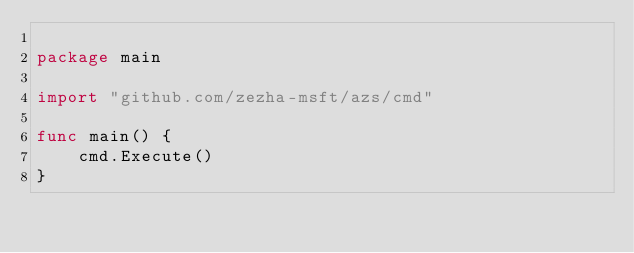Convert code to text. <code><loc_0><loc_0><loc_500><loc_500><_Go_>
package main

import "github.com/zezha-msft/azs/cmd"

func main() {
	cmd.Execute()
}
</code> 